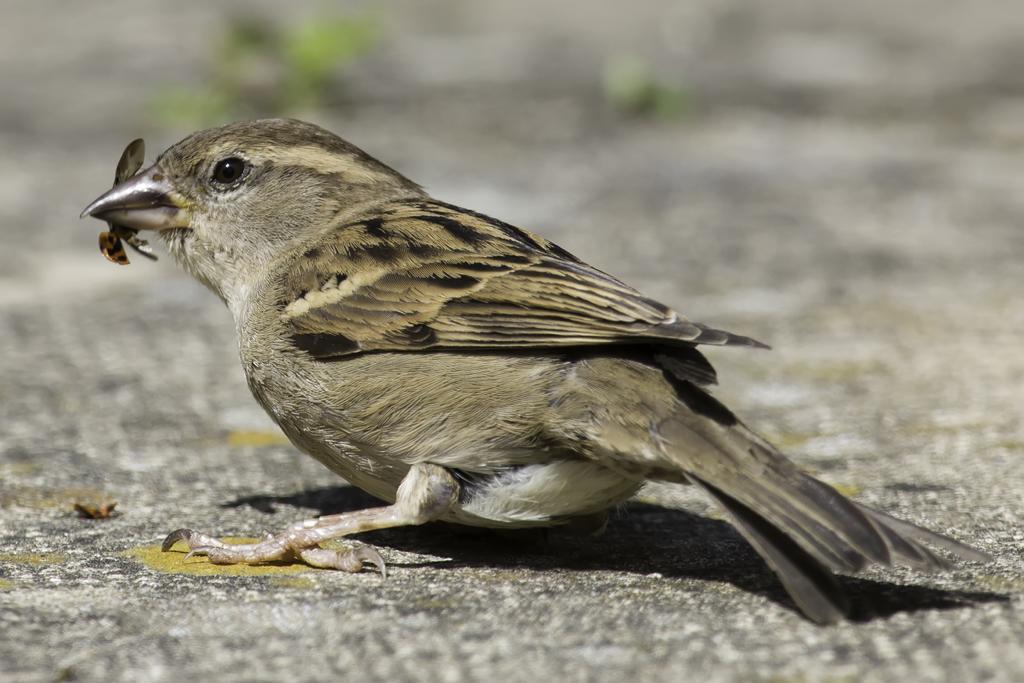Describe this image in one or two sentences. This image consists of a sparrow sitting on the road. At the bottom, there is a road. In its mouth, there is an insect. The background is blurred. 